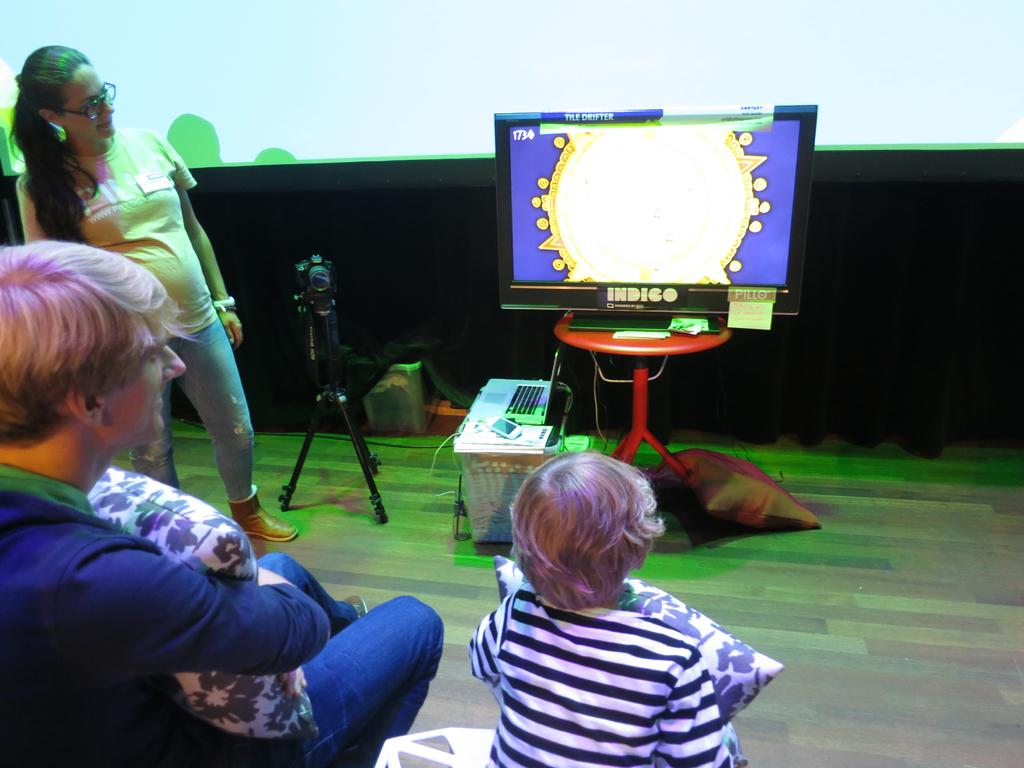How many people are in the image? There are three people in the image: a man, a woman, and a small boy. What are the people in the image doing? The man, woman, and small boy are sitting and watching television. What are they holding in their hands? They are holding pillows in their hands. What type of sponge can be seen in the image? There is no sponge present in the image. How many eyes does the small boy have in the image? The image does not show the small boy's eyes, so it is impossible to determine the number of eyes he has. 